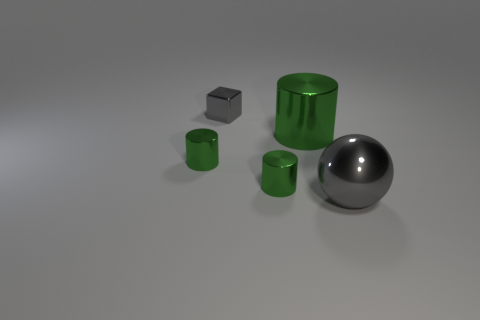There is a big object that is to the left of the large gray metal object; what is its material?
Your answer should be very brief. Metal. Are there any other metal objects of the same shape as the large gray metallic object?
Your response must be concise. No. What number of gray things have the same shape as the large green metallic thing?
Offer a terse response. 0. Is the size of the gray metallic object behind the gray shiny sphere the same as the thing on the left side of the small gray block?
Your answer should be compact. Yes. What is the shape of the gray thing that is in front of the shiny cylinder that is left of the small gray shiny object?
Provide a short and direct response. Sphere. Are there the same number of small green metallic cylinders that are in front of the gray metal sphere and small gray cubes?
Provide a succinct answer. No. The small thing to the right of the gray metal object behind the green cylinder that is to the left of the tiny metallic block is made of what material?
Make the answer very short. Metal. Are there any metal things of the same size as the cube?
Your answer should be very brief. Yes. The small gray object has what shape?
Your answer should be very brief. Cube. What number of cylinders are large green matte things or small green objects?
Offer a very short reply. 2. 